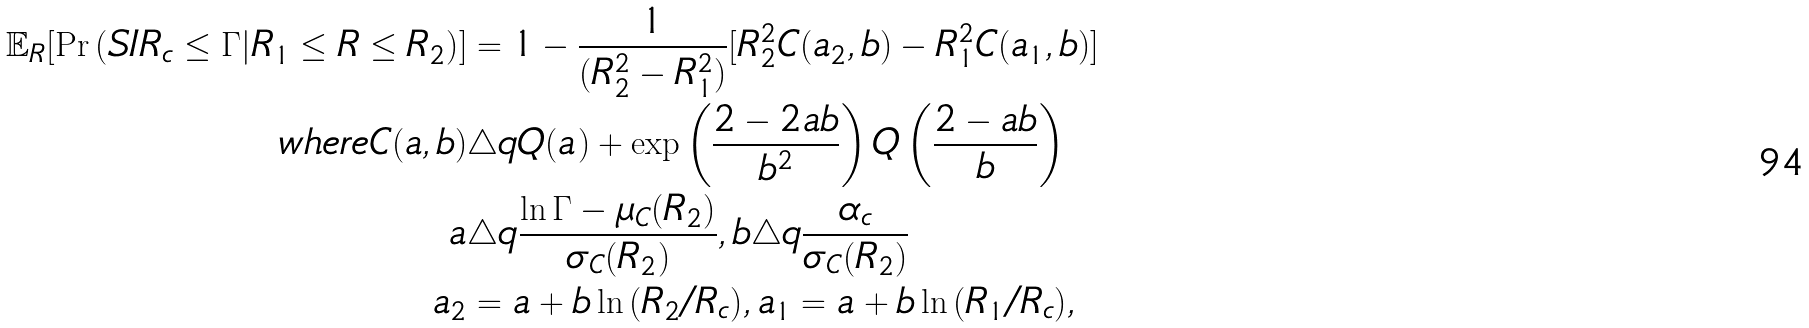Convert formula to latex. <formula><loc_0><loc_0><loc_500><loc_500>\mathbb { E } _ { R } [ \Pr { ( S I R _ { c } \leq \Gamma | R _ { 1 } \leq R \leq R _ { 2 } ) } ] & = 1 - \frac { 1 } { ( R _ { 2 } ^ { 2 } - R _ { 1 } ^ { 2 } ) } [ R _ { 2 } ^ { 2 } C ( a _ { 2 } , b ) - R _ { 1 } ^ { 2 } C ( a _ { 1 } , b ) ] \\ w h e r e C ( a , b ) & \triangle q Q ( a ) + \exp \left ( \frac { 2 - 2 a b } { b ^ { 2 } } \right ) Q \left ( \frac { 2 - a b } { b } \right ) \\ a & \triangle q \frac { \ln { \Gamma } - \mu _ { C } ( R _ { 2 } ) } { \sigma _ { C } ( R _ { 2 } ) } , b \triangle q \frac { \alpha _ { c } } { \sigma _ { C } ( R _ { 2 } ) } \\ a _ { 2 } & = a + b \ln { ( R _ { 2 } / R _ { c } ) } , a _ { 1 } = a + b \ln { ( R _ { 1 } / R _ { c } ) } ,</formula> 